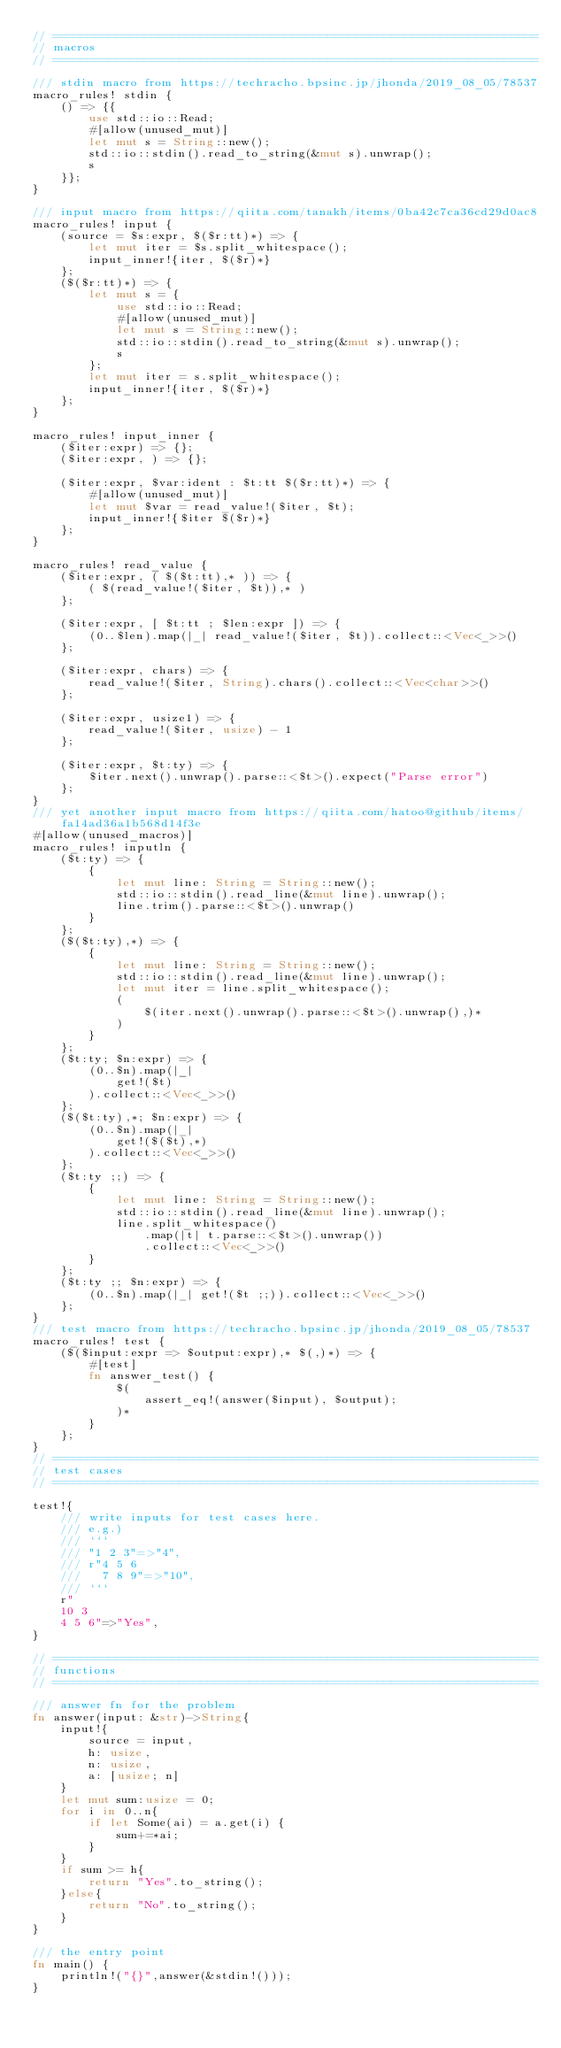Convert code to text. <code><loc_0><loc_0><loc_500><loc_500><_Rust_>// =====================================================================
// macros
// =====================================================================

/// stdin macro from https://techracho.bpsinc.jp/jhonda/2019_08_05/78537
macro_rules! stdin {
    () => {{
        use std::io::Read;
        #[allow(unused_mut)]
        let mut s = String::new();
        std::io::stdin().read_to_string(&mut s).unwrap();
        s
    }};
}

/// input macro from https://qiita.com/tanakh/items/0ba42c7ca36cd29d0ac8
macro_rules! input {
    (source = $s:expr, $($r:tt)*) => {
        let mut iter = $s.split_whitespace();
        input_inner!{iter, $($r)*}
    };
    ($($r:tt)*) => {
        let mut s = {
            use std::io::Read;
            #[allow(unused_mut)]
            let mut s = String::new();
            std::io::stdin().read_to_string(&mut s).unwrap();
            s
        };
        let mut iter = s.split_whitespace();
        input_inner!{iter, $($r)*}
    };
}

macro_rules! input_inner {
    ($iter:expr) => {};
    ($iter:expr, ) => {};

    ($iter:expr, $var:ident : $t:tt $($r:tt)*) => {
        #[allow(unused_mut)]
        let mut $var = read_value!($iter, $t);
        input_inner!{$iter $($r)*}
    };
}

macro_rules! read_value {
    ($iter:expr, ( $($t:tt),* )) => {
        ( $(read_value!($iter, $t)),* )
    };

    ($iter:expr, [ $t:tt ; $len:expr ]) => {
        (0..$len).map(|_| read_value!($iter, $t)).collect::<Vec<_>>()
    };

    ($iter:expr, chars) => {
        read_value!($iter, String).chars().collect::<Vec<char>>()
    };

    ($iter:expr, usize1) => {
        read_value!($iter, usize) - 1
    };

    ($iter:expr, $t:ty) => {
        $iter.next().unwrap().parse::<$t>().expect("Parse error")
    };
}
/// yet another input macro from https://qiita.com/hatoo@github/items/fa14ad36a1b568d14f3e
#[allow(unused_macros)]
macro_rules! inputln {
    ($t:ty) => {
        {
            let mut line: String = String::new();
            std::io::stdin().read_line(&mut line).unwrap();
            line.trim().parse::<$t>().unwrap()
        }
    };
    ($($t:ty),*) => {
        {
            let mut line: String = String::new();
            std::io::stdin().read_line(&mut line).unwrap();
            let mut iter = line.split_whitespace();
            (
                $(iter.next().unwrap().parse::<$t>().unwrap(),)*
            )
        }
    };
    ($t:ty; $n:expr) => {
        (0..$n).map(|_|
            get!($t)
        ).collect::<Vec<_>>()
    };
    ($($t:ty),*; $n:expr) => {
        (0..$n).map(|_|
            get!($($t),*)
        ).collect::<Vec<_>>()
    };
    ($t:ty ;;) => {
        {
            let mut line: String = String::new();
            std::io::stdin().read_line(&mut line).unwrap();
            line.split_whitespace()
                .map(|t| t.parse::<$t>().unwrap())
                .collect::<Vec<_>>()
        }
    };
    ($t:ty ;; $n:expr) => {
        (0..$n).map(|_| get!($t ;;)).collect::<Vec<_>>()
    };
}
/// test macro from https://techracho.bpsinc.jp/jhonda/2019_08_05/78537
macro_rules! test {
    ($($input:expr => $output:expr),* $(,)*) => {
        #[test]
        fn answer_test() {
            $(
                assert_eq!(answer($input), $output);
            )*
        }
    };
}
// =====================================================================
// test cases
// =====================================================================

test!{
    /// write inputs for test cases here.
    /// e.g.) 
    /// ```
    /// "1 2 3"=>"4",
    /// r"4 5 6
    ///   7 8 9"=>"10",
    /// ```
    r"
    10 3
    4 5 6"=>"Yes",
}

// =====================================================================
// functions
// =====================================================================

/// answer fn for the problem
fn answer(input: &str)->String{
    input!{
        source = input,
        h: usize,
        n: usize,
        a: [usize; n]
    }
    let mut sum:usize = 0;
    for i in 0..n{
        if let Some(ai) = a.get(i) {
            sum+=*ai;
        }
    }
    if sum >= h{
        return "Yes".to_string();
    }else{
        return "No".to_string();
    }
}

/// the entry point
fn main() {
    println!("{}",answer(&stdin!()));
}
</code> 